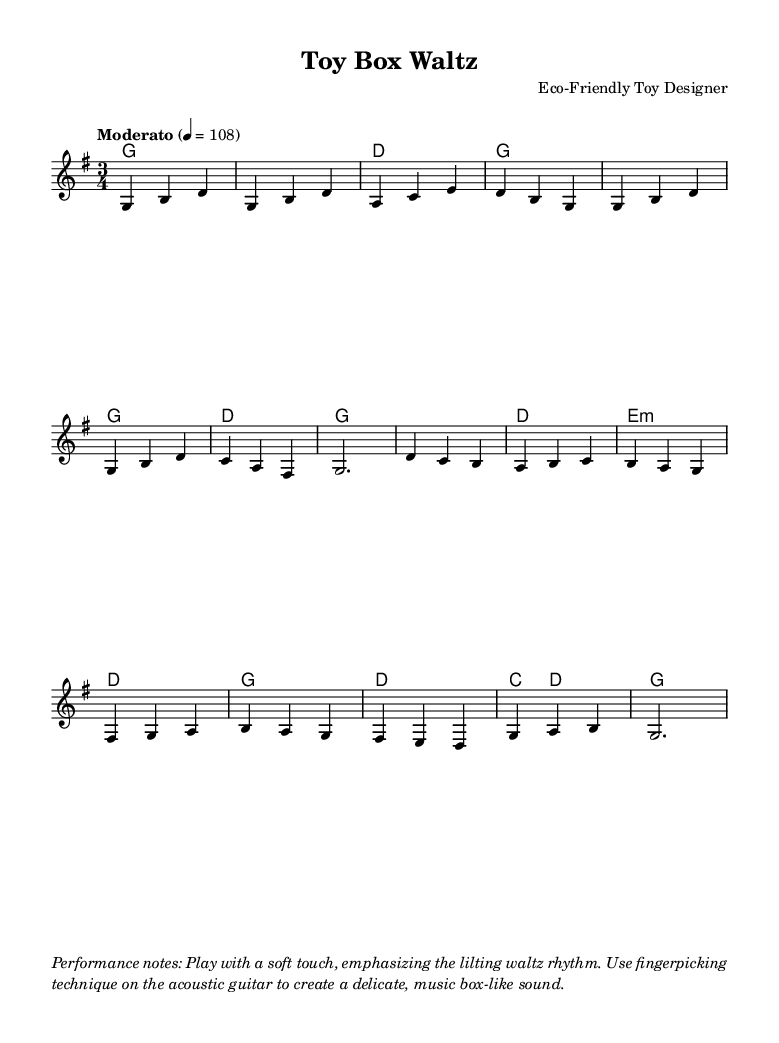What is the key signature of this music? The key signature is indicated at the beginning of the score. Here, it shows one sharp, which means the piece is in G major.
Answer: G major What is the time signature of this music? The time signature is found right after the key signature. It shows three beats per measure, indicated as 3/4.
Answer: 3/4 What is the tempo marking for this piece? The tempo is stated at the beginning of the score, where it reads "Moderato" and mentions a metronome marking of quarter note = 108.
Answer: Moderato What is the harmony’s first chord? The first chord in the harmony section is presented at the beginning. It shows a G major chord denoted as 'g' in the chord mode.
Answer: G What techniques are suggested for performance? In the performance notes section, it describes playing with a soft touch and emphasizes the lilting waltz rhythm while using fingerpicking technique.
Answer: Soft touch, fingerpicking How does the melody relate to the waltz feel? The melody is structured in a way that fits within the 3/4 time signature, creating a lilting, dance-like quality typical of a waltz. This is reflected in the phrasing and note patterns, which support a gentle sway.
Answer: Waltz feel 